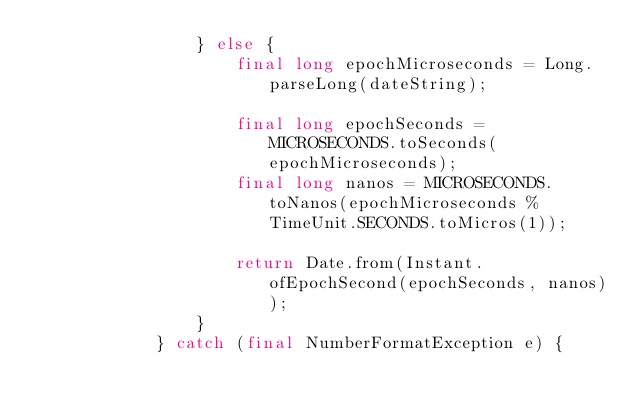Convert code to text. <code><loc_0><loc_0><loc_500><loc_500><_Java_>                } else {
                    final long epochMicroseconds = Long.parseLong(dateString);

                    final long epochSeconds = MICROSECONDS.toSeconds(epochMicroseconds);
                    final long nanos = MICROSECONDS.toNanos(epochMicroseconds % TimeUnit.SECONDS.toMicros(1));

                    return Date.from(Instant.ofEpochSecond(epochSeconds, nanos));
                }
            } catch (final NumberFormatException e) {</code> 